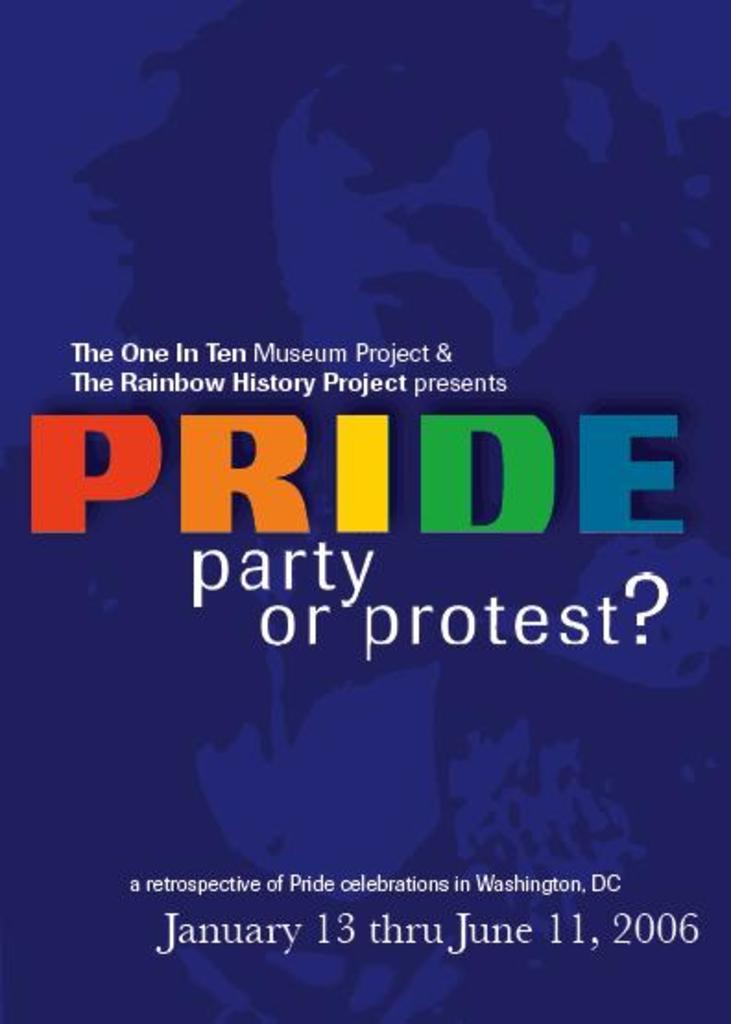What kind of party is this poster asking?
Give a very brief answer. Pride. What is the date on the poster?
Provide a succinct answer. January 13 thru june 11, 2006. 